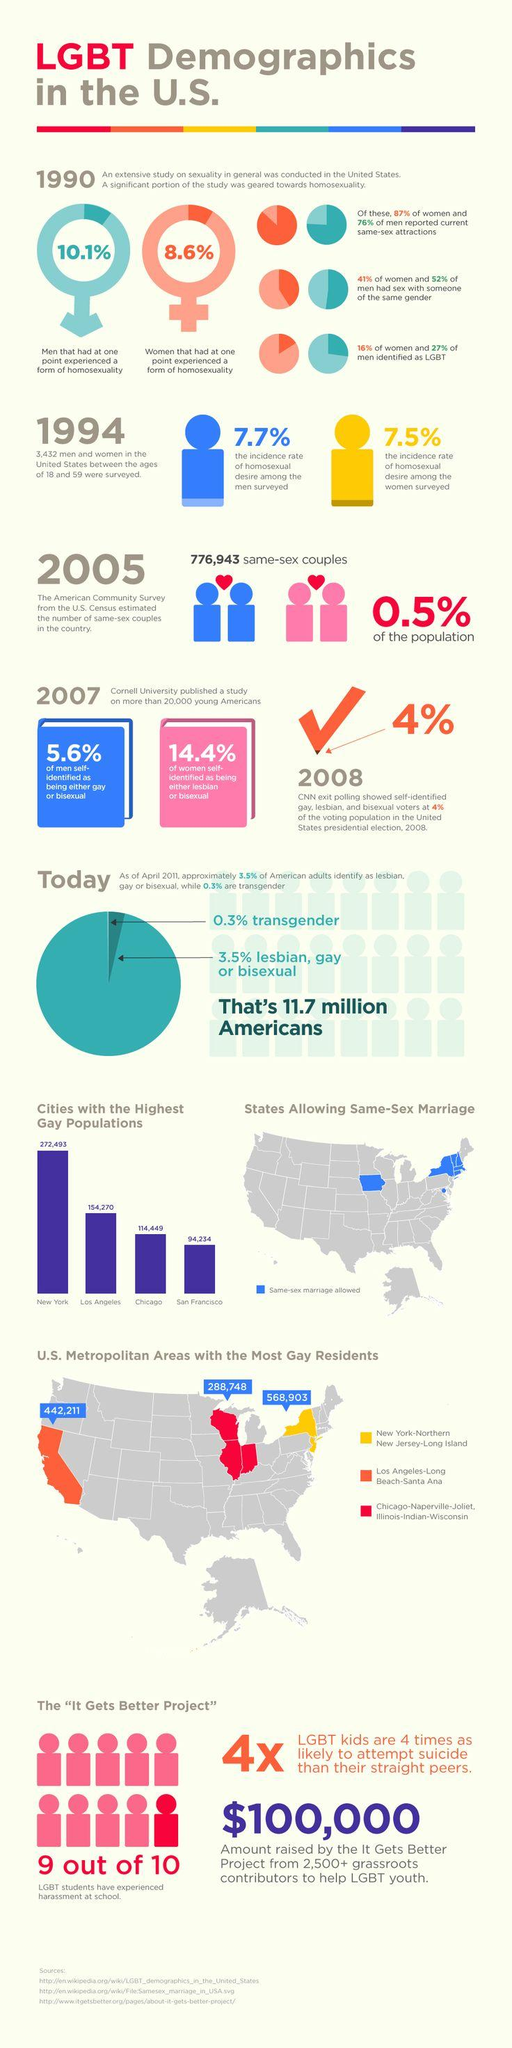Outline some significant characteristics in this image. According to the latest data, the area with the highest concentration of gay residents in the United States is New York-Northern New Jersey-Long Island. Los Angeles has the second highest gay population among cities. According to a recent survey, 11.7 million Americans identify as lesbian, gay, bisexual, or transgender. According to recent data, only 0.5% of the population identifies as being in a same-sex relationship. 